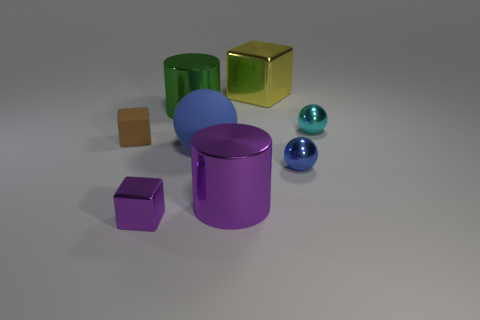Subtract all cylinders. How many objects are left? 6 Subtract 1 purple cylinders. How many objects are left? 7 Subtract all tiny yellow cylinders. Subtract all cyan shiny spheres. How many objects are left? 7 Add 4 big blocks. How many big blocks are left? 5 Add 6 blue metal cubes. How many blue metal cubes exist? 6 